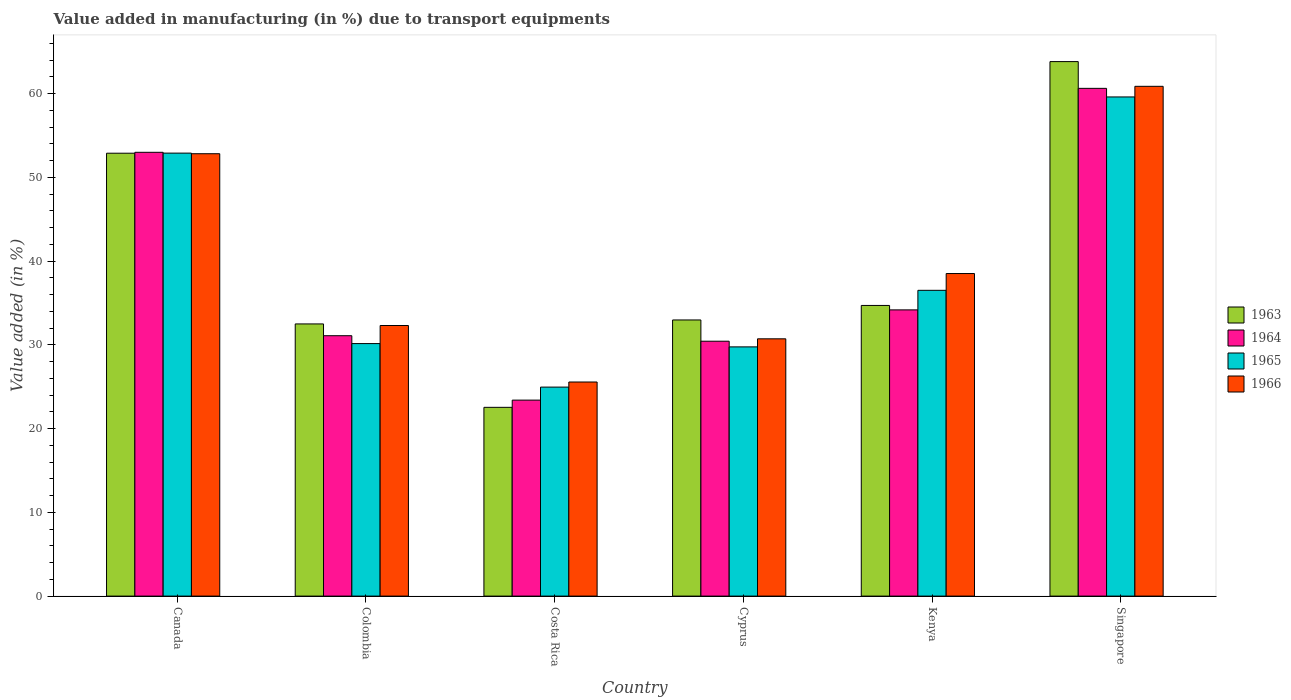How many groups of bars are there?
Offer a terse response. 6. Are the number of bars per tick equal to the number of legend labels?
Keep it short and to the point. Yes. How many bars are there on the 4th tick from the left?
Offer a terse response. 4. How many bars are there on the 1st tick from the right?
Provide a short and direct response. 4. What is the label of the 5th group of bars from the left?
Ensure brevity in your answer.  Kenya. In how many cases, is the number of bars for a given country not equal to the number of legend labels?
Provide a short and direct response. 0. What is the percentage of value added in manufacturing due to transport equipments in 1966 in Kenya?
Provide a succinct answer. 38.51. Across all countries, what is the maximum percentage of value added in manufacturing due to transport equipments in 1964?
Provide a succinct answer. 60.62. Across all countries, what is the minimum percentage of value added in manufacturing due to transport equipments in 1966?
Give a very brief answer. 25.56. In which country was the percentage of value added in manufacturing due to transport equipments in 1964 maximum?
Offer a terse response. Singapore. What is the total percentage of value added in manufacturing due to transport equipments in 1963 in the graph?
Your answer should be very brief. 239.38. What is the difference between the percentage of value added in manufacturing due to transport equipments in 1964 in Colombia and that in Singapore?
Offer a very short reply. -29.53. What is the difference between the percentage of value added in manufacturing due to transport equipments in 1965 in Costa Rica and the percentage of value added in manufacturing due to transport equipments in 1964 in Canada?
Offer a terse response. -28.03. What is the average percentage of value added in manufacturing due to transport equipments in 1966 per country?
Your response must be concise. 40.13. What is the difference between the percentage of value added in manufacturing due to transport equipments of/in 1965 and percentage of value added in manufacturing due to transport equipments of/in 1964 in Cyprus?
Provide a short and direct response. -0.68. What is the ratio of the percentage of value added in manufacturing due to transport equipments in 1966 in Canada to that in Singapore?
Provide a short and direct response. 0.87. Is the percentage of value added in manufacturing due to transport equipments in 1966 in Colombia less than that in Costa Rica?
Ensure brevity in your answer.  No. What is the difference between the highest and the second highest percentage of value added in manufacturing due to transport equipments in 1966?
Your answer should be very brief. -22.35. What is the difference between the highest and the lowest percentage of value added in manufacturing due to transport equipments in 1965?
Offer a very short reply. 34.64. In how many countries, is the percentage of value added in manufacturing due to transport equipments in 1965 greater than the average percentage of value added in manufacturing due to transport equipments in 1965 taken over all countries?
Offer a very short reply. 2. What does the 3rd bar from the left in Costa Rica represents?
Offer a very short reply. 1965. What does the 2nd bar from the right in Canada represents?
Give a very brief answer. 1965. Is it the case that in every country, the sum of the percentage of value added in manufacturing due to transport equipments in 1963 and percentage of value added in manufacturing due to transport equipments in 1964 is greater than the percentage of value added in manufacturing due to transport equipments in 1965?
Give a very brief answer. Yes. Are all the bars in the graph horizontal?
Your response must be concise. No. Are the values on the major ticks of Y-axis written in scientific E-notation?
Your answer should be very brief. No. Does the graph contain any zero values?
Ensure brevity in your answer.  No. Does the graph contain grids?
Keep it short and to the point. No. Where does the legend appear in the graph?
Provide a succinct answer. Center right. What is the title of the graph?
Offer a terse response. Value added in manufacturing (in %) due to transport equipments. Does "1968" appear as one of the legend labels in the graph?
Give a very brief answer. No. What is the label or title of the X-axis?
Keep it short and to the point. Country. What is the label or title of the Y-axis?
Provide a succinct answer. Value added (in %). What is the Value added (in %) in 1963 in Canada?
Give a very brief answer. 52.87. What is the Value added (in %) in 1964 in Canada?
Your response must be concise. 52.98. What is the Value added (in %) of 1965 in Canada?
Provide a succinct answer. 52.89. What is the Value added (in %) in 1966 in Canada?
Keep it short and to the point. 52.81. What is the Value added (in %) in 1963 in Colombia?
Make the answer very short. 32.49. What is the Value added (in %) of 1964 in Colombia?
Keep it short and to the point. 31.09. What is the Value added (in %) of 1965 in Colombia?
Make the answer very short. 30.15. What is the Value added (in %) in 1966 in Colombia?
Give a very brief answer. 32.3. What is the Value added (in %) in 1963 in Costa Rica?
Provide a short and direct response. 22.53. What is the Value added (in %) in 1964 in Costa Rica?
Your answer should be compact. 23.4. What is the Value added (in %) in 1965 in Costa Rica?
Your answer should be compact. 24.95. What is the Value added (in %) in 1966 in Costa Rica?
Your answer should be very brief. 25.56. What is the Value added (in %) of 1963 in Cyprus?
Provide a succinct answer. 32.97. What is the Value added (in %) of 1964 in Cyprus?
Your response must be concise. 30.43. What is the Value added (in %) in 1965 in Cyprus?
Your answer should be compact. 29.75. What is the Value added (in %) in 1966 in Cyprus?
Offer a very short reply. 30.72. What is the Value added (in %) of 1963 in Kenya?
Your answer should be very brief. 34.7. What is the Value added (in %) in 1964 in Kenya?
Your response must be concise. 34.17. What is the Value added (in %) of 1965 in Kenya?
Offer a terse response. 36.5. What is the Value added (in %) of 1966 in Kenya?
Offer a very short reply. 38.51. What is the Value added (in %) in 1963 in Singapore?
Offer a very short reply. 63.81. What is the Value added (in %) in 1964 in Singapore?
Offer a very short reply. 60.62. What is the Value added (in %) of 1965 in Singapore?
Offer a very short reply. 59.59. What is the Value added (in %) of 1966 in Singapore?
Provide a succinct answer. 60.86. Across all countries, what is the maximum Value added (in %) in 1963?
Provide a succinct answer. 63.81. Across all countries, what is the maximum Value added (in %) of 1964?
Keep it short and to the point. 60.62. Across all countries, what is the maximum Value added (in %) of 1965?
Your answer should be compact. 59.59. Across all countries, what is the maximum Value added (in %) in 1966?
Make the answer very short. 60.86. Across all countries, what is the minimum Value added (in %) of 1963?
Ensure brevity in your answer.  22.53. Across all countries, what is the minimum Value added (in %) in 1964?
Your response must be concise. 23.4. Across all countries, what is the minimum Value added (in %) of 1965?
Provide a succinct answer. 24.95. Across all countries, what is the minimum Value added (in %) of 1966?
Keep it short and to the point. 25.56. What is the total Value added (in %) of 1963 in the graph?
Your answer should be very brief. 239.38. What is the total Value added (in %) of 1964 in the graph?
Give a very brief answer. 232.68. What is the total Value added (in %) in 1965 in the graph?
Offer a terse response. 233.83. What is the total Value added (in %) of 1966 in the graph?
Keep it short and to the point. 240.76. What is the difference between the Value added (in %) in 1963 in Canada and that in Colombia?
Ensure brevity in your answer.  20.38. What is the difference between the Value added (in %) in 1964 in Canada and that in Colombia?
Your answer should be compact. 21.9. What is the difference between the Value added (in %) of 1965 in Canada and that in Colombia?
Your answer should be compact. 22.74. What is the difference between the Value added (in %) in 1966 in Canada and that in Colombia?
Provide a short and direct response. 20.51. What is the difference between the Value added (in %) in 1963 in Canada and that in Costa Rica?
Keep it short and to the point. 30.34. What is the difference between the Value added (in %) in 1964 in Canada and that in Costa Rica?
Offer a very short reply. 29.59. What is the difference between the Value added (in %) of 1965 in Canada and that in Costa Rica?
Your answer should be compact. 27.93. What is the difference between the Value added (in %) in 1966 in Canada and that in Costa Rica?
Ensure brevity in your answer.  27.25. What is the difference between the Value added (in %) in 1963 in Canada and that in Cyprus?
Provide a succinct answer. 19.91. What is the difference between the Value added (in %) of 1964 in Canada and that in Cyprus?
Your answer should be compact. 22.55. What is the difference between the Value added (in %) of 1965 in Canada and that in Cyprus?
Your response must be concise. 23.13. What is the difference between the Value added (in %) of 1966 in Canada and that in Cyprus?
Make the answer very short. 22.1. What is the difference between the Value added (in %) in 1963 in Canada and that in Kenya?
Offer a terse response. 18.17. What is the difference between the Value added (in %) in 1964 in Canada and that in Kenya?
Provide a short and direct response. 18.81. What is the difference between the Value added (in %) of 1965 in Canada and that in Kenya?
Offer a terse response. 16.38. What is the difference between the Value added (in %) in 1966 in Canada and that in Kenya?
Ensure brevity in your answer.  14.3. What is the difference between the Value added (in %) in 1963 in Canada and that in Singapore?
Offer a very short reply. -10.94. What is the difference between the Value added (in %) of 1964 in Canada and that in Singapore?
Ensure brevity in your answer.  -7.63. What is the difference between the Value added (in %) in 1965 in Canada and that in Singapore?
Ensure brevity in your answer.  -6.71. What is the difference between the Value added (in %) of 1966 in Canada and that in Singapore?
Provide a short and direct response. -8.05. What is the difference between the Value added (in %) in 1963 in Colombia and that in Costa Rica?
Provide a succinct answer. 9.96. What is the difference between the Value added (in %) in 1964 in Colombia and that in Costa Rica?
Your response must be concise. 7.69. What is the difference between the Value added (in %) of 1965 in Colombia and that in Costa Rica?
Offer a terse response. 5.2. What is the difference between the Value added (in %) of 1966 in Colombia and that in Costa Rica?
Provide a short and direct response. 6.74. What is the difference between the Value added (in %) in 1963 in Colombia and that in Cyprus?
Your answer should be very brief. -0.47. What is the difference between the Value added (in %) in 1964 in Colombia and that in Cyprus?
Give a very brief answer. 0.66. What is the difference between the Value added (in %) in 1965 in Colombia and that in Cyprus?
Provide a succinct answer. 0.39. What is the difference between the Value added (in %) of 1966 in Colombia and that in Cyprus?
Your answer should be very brief. 1.59. What is the difference between the Value added (in %) of 1963 in Colombia and that in Kenya?
Your answer should be compact. -2.21. What is the difference between the Value added (in %) of 1964 in Colombia and that in Kenya?
Offer a terse response. -3.08. What is the difference between the Value added (in %) of 1965 in Colombia and that in Kenya?
Your answer should be compact. -6.36. What is the difference between the Value added (in %) in 1966 in Colombia and that in Kenya?
Your answer should be very brief. -6.2. What is the difference between the Value added (in %) in 1963 in Colombia and that in Singapore?
Offer a terse response. -31.32. What is the difference between the Value added (in %) of 1964 in Colombia and that in Singapore?
Your answer should be very brief. -29.53. What is the difference between the Value added (in %) of 1965 in Colombia and that in Singapore?
Provide a short and direct response. -29.45. What is the difference between the Value added (in %) of 1966 in Colombia and that in Singapore?
Ensure brevity in your answer.  -28.56. What is the difference between the Value added (in %) in 1963 in Costa Rica and that in Cyprus?
Provide a succinct answer. -10.43. What is the difference between the Value added (in %) in 1964 in Costa Rica and that in Cyprus?
Your answer should be compact. -7.03. What is the difference between the Value added (in %) in 1965 in Costa Rica and that in Cyprus?
Your answer should be very brief. -4.8. What is the difference between the Value added (in %) in 1966 in Costa Rica and that in Cyprus?
Provide a succinct answer. -5.16. What is the difference between the Value added (in %) of 1963 in Costa Rica and that in Kenya?
Offer a terse response. -12.17. What is the difference between the Value added (in %) of 1964 in Costa Rica and that in Kenya?
Your answer should be compact. -10.77. What is the difference between the Value added (in %) of 1965 in Costa Rica and that in Kenya?
Offer a terse response. -11.55. What is the difference between the Value added (in %) of 1966 in Costa Rica and that in Kenya?
Keep it short and to the point. -12.95. What is the difference between the Value added (in %) in 1963 in Costa Rica and that in Singapore?
Offer a terse response. -41.28. What is the difference between the Value added (in %) of 1964 in Costa Rica and that in Singapore?
Provide a succinct answer. -37.22. What is the difference between the Value added (in %) in 1965 in Costa Rica and that in Singapore?
Provide a succinct answer. -34.64. What is the difference between the Value added (in %) of 1966 in Costa Rica and that in Singapore?
Your answer should be compact. -35.3. What is the difference between the Value added (in %) in 1963 in Cyprus and that in Kenya?
Keep it short and to the point. -1.73. What is the difference between the Value added (in %) in 1964 in Cyprus and that in Kenya?
Ensure brevity in your answer.  -3.74. What is the difference between the Value added (in %) in 1965 in Cyprus and that in Kenya?
Your response must be concise. -6.75. What is the difference between the Value added (in %) of 1966 in Cyprus and that in Kenya?
Your answer should be compact. -7.79. What is the difference between the Value added (in %) in 1963 in Cyprus and that in Singapore?
Ensure brevity in your answer.  -30.84. What is the difference between the Value added (in %) in 1964 in Cyprus and that in Singapore?
Provide a succinct answer. -30.19. What is the difference between the Value added (in %) of 1965 in Cyprus and that in Singapore?
Ensure brevity in your answer.  -29.84. What is the difference between the Value added (in %) in 1966 in Cyprus and that in Singapore?
Your answer should be very brief. -30.14. What is the difference between the Value added (in %) in 1963 in Kenya and that in Singapore?
Your answer should be very brief. -29.11. What is the difference between the Value added (in %) of 1964 in Kenya and that in Singapore?
Give a very brief answer. -26.45. What is the difference between the Value added (in %) of 1965 in Kenya and that in Singapore?
Provide a succinct answer. -23.09. What is the difference between the Value added (in %) in 1966 in Kenya and that in Singapore?
Provide a short and direct response. -22.35. What is the difference between the Value added (in %) of 1963 in Canada and the Value added (in %) of 1964 in Colombia?
Make the answer very short. 21.79. What is the difference between the Value added (in %) of 1963 in Canada and the Value added (in %) of 1965 in Colombia?
Provide a succinct answer. 22.73. What is the difference between the Value added (in %) in 1963 in Canada and the Value added (in %) in 1966 in Colombia?
Give a very brief answer. 20.57. What is the difference between the Value added (in %) of 1964 in Canada and the Value added (in %) of 1965 in Colombia?
Make the answer very short. 22.84. What is the difference between the Value added (in %) in 1964 in Canada and the Value added (in %) in 1966 in Colombia?
Make the answer very short. 20.68. What is the difference between the Value added (in %) of 1965 in Canada and the Value added (in %) of 1966 in Colombia?
Keep it short and to the point. 20.58. What is the difference between the Value added (in %) of 1963 in Canada and the Value added (in %) of 1964 in Costa Rica?
Make the answer very short. 29.48. What is the difference between the Value added (in %) of 1963 in Canada and the Value added (in %) of 1965 in Costa Rica?
Make the answer very short. 27.92. What is the difference between the Value added (in %) in 1963 in Canada and the Value added (in %) in 1966 in Costa Rica?
Keep it short and to the point. 27.31. What is the difference between the Value added (in %) in 1964 in Canada and the Value added (in %) in 1965 in Costa Rica?
Offer a very short reply. 28.03. What is the difference between the Value added (in %) of 1964 in Canada and the Value added (in %) of 1966 in Costa Rica?
Provide a succinct answer. 27.42. What is the difference between the Value added (in %) of 1965 in Canada and the Value added (in %) of 1966 in Costa Rica?
Make the answer very short. 27.33. What is the difference between the Value added (in %) of 1963 in Canada and the Value added (in %) of 1964 in Cyprus?
Your answer should be compact. 22.44. What is the difference between the Value added (in %) of 1963 in Canada and the Value added (in %) of 1965 in Cyprus?
Your response must be concise. 23.12. What is the difference between the Value added (in %) in 1963 in Canada and the Value added (in %) in 1966 in Cyprus?
Provide a short and direct response. 22.16. What is the difference between the Value added (in %) in 1964 in Canada and the Value added (in %) in 1965 in Cyprus?
Your response must be concise. 23.23. What is the difference between the Value added (in %) in 1964 in Canada and the Value added (in %) in 1966 in Cyprus?
Make the answer very short. 22.27. What is the difference between the Value added (in %) in 1965 in Canada and the Value added (in %) in 1966 in Cyprus?
Your answer should be compact. 22.17. What is the difference between the Value added (in %) of 1963 in Canada and the Value added (in %) of 1964 in Kenya?
Give a very brief answer. 18.7. What is the difference between the Value added (in %) in 1963 in Canada and the Value added (in %) in 1965 in Kenya?
Give a very brief answer. 16.37. What is the difference between the Value added (in %) in 1963 in Canada and the Value added (in %) in 1966 in Kenya?
Your response must be concise. 14.37. What is the difference between the Value added (in %) of 1964 in Canada and the Value added (in %) of 1965 in Kenya?
Give a very brief answer. 16.48. What is the difference between the Value added (in %) of 1964 in Canada and the Value added (in %) of 1966 in Kenya?
Keep it short and to the point. 14.47. What is the difference between the Value added (in %) in 1965 in Canada and the Value added (in %) in 1966 in Kenya?
Make the answer very short. 14.38. What is the difference between the Value added (in %) of 1963 in Canada and the Value added (in %) of 1964 in Singapore?
Give a very brief answer. -7.74. What is the difference between the Value added (in %) in 1963 in Canada and the Value added (in %) in 1965 in Singapore?
Your response must be concise. -6.72. What is the difference between the Value added (in %) of 1963 in Canada and the Value added (in %) of 1966 in Singapore?
Make the answer very short. -7.99. What is the difference between the Value added (in %) in 1964 in Canada and the Value added (in %) in 1965 in Singapore?
Ensure brevity in your answer.  -6.61. What is the difference between the Value added (in %) in 1964 in Canada and the Value added (in %) in 1966 in Singapore?
Provide a short and direct response. -7.88. What is the difference between the Value added (in %) of 1965 in Canada and the Value added (in %) of 1966 in Singapore?
Ensure brevity in your answer.  -7.97. What is the difference between the Value added (in %) in 1963 in Colombia and the Value added (in %) in 1964 in Costa Rica?
Provide a succinct answer. 9.1. What is the difference between the Value added (in %) in 1963 in Colombia and the Value added (in %) in 1965 in Costa Rica?
Provide a short and direct response. 7.54. What is the difference between the Value added (in %) in 1963 in Colombia and the Value added (in %) in 1966 in Costa Rica?
Make the answer very short. 6.93. What is the difference between the Value added (in %) of 1964 in Colombia and the Value added (in %) of 1965 in Costa Rica?
Your answer should be compact. 6.14. What is the difference between the Value added (in %) in 1964 in Colombia and the Value added (in %) in 1966 in Costa Rica?
Give a very brief answer. 5.53. What is the difference between the Value added (in %) of 1965 in Colombia and the Value added (in %) of 1966 in Costa Rica?
Give a very brief answer. 4.59. What is the difference between the Value added (in %) in 1963 in Colombia and the Value added (in %) in 1964 in Cyprus?
Provide a short and direct response. 2.06. What is the difference between the Value added (in %) in 1963 in Colombia and the Value added (in %) in 1965 in Cyprus?
Your response must be concise. 2.74. What is the difference between the Value added (in %) in 1963 in Colombia and the Value added (in %) in 1966 in Cyprus?
Your response must be concise. 1.78. What is the difference between the Value added (in %) of 1964 in Colombia and the Value added (in %) of 1965 in Cyprus?
Provide a succinct answer. 1.33. What is the difference between the Value added (in %) in 1964 in Colombia and the Value added (in %) in 1966 in Cyprus?
Give a very brief answer. 0.37. What is the difference between the Value added (in %) in 1965 in Colombia and the Value added (in %) in 1966 in Cyprus?
Provide a short and direct response. -0.57. What is the difference between the Value added (in %) of 1963 in Colombia and the Value added (in %) of 1964 in Kenya?
Your response must be concise. -1.68. What is the difference between the Value added (in %) of 1963 in Colombia and the Value added (in %) of 1965 in Kenya?
Make the answer very short. -4.01. What is the difference between the Value added (in %) in 1963 in Colombia and the Value added (in %) in 1966 in Kenya?
Provide a succinct answer. -6.01. What is the difference between the Value added (in %) of 1964 in Colombia and the Value added (in %) of 1965 in Kenya?
Your answer should be compact. -5.42. What is the difference between the Value added (in %) in 1964 in Colombia and the Value added (in %) in 1966 in Kenya?
Your answer should be compact. -7.42. What is the difference between the Value added (in %) of 1965 in Colombia and the Value added (in %) of 1966 in Kenya?
Make the answer very short. -8.36. What is the difference between the Value added (in %) of 1963 in Colombia and the Value added (in %) of 1964 in Singapore?
Your answer should be compact. -28.12. What is the difference between the Value added (in %) in 1963 in Colombia and the Value added (in %) in 1965 in Singapore?
Ensure brevity in your answer.  -27.1. What is the difference between the Value added (in %) of 1963 in Colombia and the Value added (in %) of 1966 in Singapore?
Offer a terse response. -28.37. What is the difference between the Value added (in %) in 1964 in Colombia and the Value added (in %) in 1965 in Singapore?
Give a very brief answer. -28.51. What is the difference between the Value added (in %) in 1964 in Colombia and the Value added (in %) in 1966 in Singapore?
Keep it short and to the point. -29.77. What is the difference between the Value added (in %) of 1965 in Colombia and the Value added (in %) of 1966 in Singapore?
Give a very brief answer. -30.71. What is the difference between the Value added (in %) of 1963 in Costa Rica and the Value added (in %) of 1964 in Cyprus?
Keep it short and to the point. -7.9. What is the difference between the Value added (in %) in 1963 in Costa Rica and the Value added (in %) in 1965 in Cyprus?
Keep it short and to the point. -7.22. What is the difference between the Value added (in %) of 1963 in Costa Rica and the Value added (in %) of 1966 in Cyprus?
Offer a very short reply. -8.18. What is the difference between the Value added (in %) in 1964 in Costa Rica and the Value added (in %) in 1965 in Cyprus?
Your answer should be very brief. -6.36. What is the difference between the Value added (in %) of 1964 in Costa Rica and the Value added (in %) of 1966 in Cyprus?
Keep it short and to the point. -7.32. What is the difference between the Value added (in %) of 1965 in Costa Rica and the Value added (in %) of 1966 in Cyprus?
Your response must be concise. -5.77. What is the difference between the Value added (in %) in 1963 in Costa Rica and the Value added (in %) in 1964 in Kenya?
Offer a terse response. -11.64. What is the difference between the Value added (in %) in 1963 in Costa Rica and the Value added (in %) in 1965 in Kenya?
Your answer should be very brief. -13.97. What is the difference between the Value added (in %) in 1963 in Costa Rica and the Value added (in %) in 1966 in Kenya?
Offer a terse response. -15.97. What is the difference between the Value added (in %) of 1964 in Costa Rica and the Value added (in %) of 1965 in Kenya?
Offer a very short reply. -13.11. What is the difference between the Value added (in %) of 1964 in Costa Rica and the Value added (in %) of 1966 in Kenya?
Offer a terse response. -15.11. What is the difference between the Value added (in %) in 1965 in Costa Rica and the Value added (in %) in 1966 in Kenya?
Your response must be concise. -13.56. What is the difference between the Value added (in %) in 1963 in Costa Rica and the Value added (in %) in 1964 in Singapore?
Provide a succinct answer. -38.08. What is the difference between the Value added (in %) of 1963 in Costa Rica and the Value added (in %) of 1965 in Singapore?
Offer a terse response. -37.06. What is the difference between the Value added (in %) in 1963 in Costa Rica and the Value added (in %) in 1966 in Singapore?
Give a very brief answer. -38.33. What is the difference between the Value added (in %) in 1964 in Costa Rica and the Value added (in %) in 1965 in Singapore?
Keep it short and to the point. -36.19. What is the difference between the Value added (in %) of 1964 in Costa Rica and the Value added (in %) of 1966 in Singapore?
Your answer should be very brief. -37.46. What is the difference between the Value added (in %) in 1965 in Costa Rica and the Value added (in %) in 1966 in Singapore?
Keep it short and to the point. -35.91. What is the difference between the Value added (in %) in 1963 in Cyprus and the Value added (in %) in 1964 in Kenya?
Your answer should be compact. -1.2. What is the difference between the Value added (in %) in 1963 in Cyprus and the Value added (in %) in 1965 in Kenya?
Make the answer very short. -3.54. What is the difference between the Value added (in %) in 1963 in Cyprus and the Value added (in %) in 1966 in Kenya?
Make the answer very short. -5.54. What is the difference between the Value added (in %) in 1964 in Cyprus and the Value added (in %) in 1965 in Kenya?
Make the answer very short. -6.07. What is the difference between the Value added (in %) of 1964 in Cyprus and the Value added (in %) of 1966 in Kenya?
Your response must be concise. -8.08. What is the difference between the Value added (in %) in 1965 in Cyprus and the Value added (in %) in 1966 in Kenya?
Your response must be concise. -8.75. What is the difference between the Value added (in %) of 1963 in Cyprus and the Value added (in %) of 1964 in Singapore?
Your answer should be very brief. -27.65. What is the difference between the Value added (in %) of 1963 in Cyprus and the Value added (in %) of 1965 in Singapore?
Keep it short and to the point. -26.62. What is the difference between the Value added (in %) in 1963 in Cyprus and the Value added (in %) in 1966 in Singapore?
Keep it short and to the point. -27.89. What is the difference between the Value added (in %) in 1964 in Cyprus and the Value added (in %) in 1965 in Singapore?
Offer a terse response. -29.16. What is the difference between the Value added (in %) of 1964 in Cyprus and the Value added (in %) of 1966 in Singapore?
Keep it short and to the point. -30.43. What is the difference between the Value added (in %) of 1965 in Cyprus and the Value added (in %) of 1966 in Singapore?
Your answer should be very brief. -31.11. What is the difference between the Value added (in %) of 1963 in Kenya and the Value added (in %) of 1964 in Singapore?
Provide a short and direct response. -25.92. What is the difference between the Value added (in %) in 1963 in Kenya and the Value added (in %) in 1965 in Singapore?
Give a very brief answer. -24.89. What is the difference between the Value added (in %) of 1963 in Kenya and the Value added (in %) of 1966 in Singapore?
Make the answer very short. -26.16. What is the difference between the Value added (in %) in 1964 in Kenya and the Value added (in %) in 1965 in Singapore?
Ensure brevity in your answer.  -25.42. What is the difference between the Value added (in %) of 1964 in Kenya and the Value added (in %) of 1966 in Singapore?
Your answer should be compact. -26.69. What is the difference between the Value added (in %) in 1965 in Kenya and the Value added (in %) in 1966 in Singapore?
Keep it short and to the point. -24.36. What is the average Value added (in %) in 1963 per country?
Provide a succinct answer. 39.9. What is the average Value added (in %) in 1964 per country?
Offer a very short reply. 38.78. What is the average Value added (in %) in 1965 per country?
Give a very brief answer. 38.97. What is the average Value added (in %) in 1966 per country?
Offer a terse response. 40.13. What is the difference between the Value added (in %) of 1963 and Value added (in %) of 1964 in Canada?
Provide a succinct answer. -0.11. What is the difference between the Value added (in %) of 1963 and Value added (in %) of 1965 in Canada?
Provide a short and direct response. -0.01. What is the difference between the Value added (in %) of 1963 and Value added (in %) of 1966 in Canada?
Give a very brief answer. 0.06. What is the difference between the Value added (in %) of 1964 and Value added (in %) of 1965 in Canada?
Keep it short and to the point. 0.1. What is the difference between the Value added (in %) in 1964 and Value added (in %) in 1966 in Canada?
Your answer should be very brief. 0.17. What is the difference between the Value added (in %) of 1965 and Value added (in %) of 1966 in Canada?
Offer a very short reply. 0.07. What is the difference between the Value added (in %) of 1963 and Value added (in %) of 1964 in Colombia?
Your response must be concise. 1.41. What is the difference between the Value added (in %) in 1963 and Value added (in %) in 1965 in Colombia?
Give a very brief answer. 2.35. What is the difference between the Value added (in %) in 1963 and Value added (in %) in 1966 in Colombia?
Offer a terse response. 0.19. What is the difference between the Value added (in %) of 1964 and Value added (in %) of 1965 in Colombia?
Provide a short and direct response. 0.94. What is the difference between the Value added (in %) of 1964 and Value added (in %) of 1966 in Colombia?
Your answer should be compact. -1.22. What is the difference between the Value added (in %) in 1965 and Value added (in %) in 1966 in Colombia?
Provide a succinct answer. -2.16. What is the difference between the Value added (in %) of 1963 and Value added (in %) of 1964 in Costa Rica?
Your response must be concise. -0.86. What is the difference between the Value added (in %) of 1963 and Value added (in %) of 1965 in Costa Rica?
Keep it short and to the point. -2.42. What is the difference between the Value added (in %) of 1963 and Value added (in %) of 1966 in Costa Rica?
Give a very brief answer. -3.03. What is the difference between the Value added (in %) in 1964 and Value added (in %) in 1965 in Costa Rica?
Keep it short and to the point. -1.55. What is the difference between the Value added (in %) in 1964 and Value added (in %) in 1966 in Costa Rica?
Offer a very short reply. -2.16. What is the difference between the Value added (in %) of 1965 and Value added (in %) of 1966 in Costa Rica?
Keep it short and to the point. -0.61. What is the difference between the Value added (in %) of 1963 and Value added (in %) of 1964 in Cyprus?
Provide a succinct answer. 2.54. What is the difference between the Value added (in %) in 1963 and Value added (in %) in 1965 in Cyprus?
Your response must be concise. 3.21. What is the difference between the Value added (in %) in 1963 and Value added (in %) in 1966 in Cyprus?
Provide a short and direct response. 2.25. What is the difference between the Value added (in %) of 1964 and Value added (in %) of 1965 in Cyprus?
Offer a terse response. 0.68. What is the difference between the Value added (in %) of 1964 and Value added (in %) of 1966 in Cyprus?
Provide a short and direct response. -0.29. What is the difference between the Value added (in %) of 1965 and Value added (in %) of 1966 in Cyprus?
Your response must be concise. -0.96. What is the difference between the Value added (in %) of 1963 and Value added (in %) of 1964 in Kenya?
Your answer should be very brief. 0.53. What is the difference between the Value added (in %) in 1963 and Value added (in %) in 1965 in Kenya?
Offer a very short reply. -1.8. What is the difference between the Value added (in %) of 1963 and Value added (in %) of 1966 in Kenya?
Your answer should be compact. -3.81. What is the difference between the Value added (in %) in 1964 and Value added (in %) in 1965 in Kenya?
Your answer should be very brief. -2.33. What is the difference between the Value added (in %) in 1964 and Value added (in %) in 1966 in Kenya?
Provide a short and direct response. -4.34. What is the difference between the Value added (in %) of 1965 and Value added (in %) of 1966 in Kenya?
Keep it short and to the point. -2. What is the difference between the Value added (in %) of 1963 and Value added (in %) of 1964 in Singapore?
Your response must be concise. 3.19. What is the difference between the Value added (in %) in 1963 and Value added (in %) in 1965 in Singapore?
Offer a terse response. 4.22. What is the difference between the Value added (in %) in 1963 and Value added (in %) in 1966 in Singapore?
Offer a terse response. 2.95. What is the difference between the Value added (in %) of 1964 and Value added (in %) of 1965 in Singapore?
Your answer should be compact. 1.03. What is the difference between the Value added (in %) in 1964 and Value added (in %) in 1966 in Singapore?
Your response must be concise. -0.24. What is the difference between the Value added (in %) of 1965 and Value added (in %) of 1966 in Singapore?
Make the answer very short. -1.27. What is the ratio of the Value added (in %) of 1963 in Canada to that in Colombia?
Give a very brief answer. 1.63. What is the ratio of the Value added (in %) of 1964 in Canada to that in Colombia?
Your answer should be very brief. 1.7. What is the ratio of the Value added (in %) of 1965 in Canada to that in Colombia?
Give a very brief answer. 1.75. What is the ratio of the Value added (in %) in 1966 in Canada to that in Colombia?
Ensure brevity in your answer.  1.63. What is the ratio of the Value added (in %) in 1963 in Canada to that in Costa Rica?
Provide a short and direct response. 2.35. What is the ratio of the Value added (in %) of 1964 in Canada to that in Costa Rica?
Keep it short and to the point. 2.26. What is the ratio of the Value added (in %) in 1965 in Canada to that in Costa Rica?
Provide a succinct answer. 2.12. What is the ratio of the Value added (in %) of 1966 in Canada to that in Costa Rica?
Offer a very short reply. 2.07. What is the ratio of the Value added (in %) of 1963 in Canada to that in Cyprus?
Ensure brevity in your answer.  1.6. What is the ratio of the Value added (in %) in 1964 in Canada to that in Cyprus?
Offer a terse response. 1.74. What is the ratio of the Value added (in %) in 1965 in Canada to that in Cyprus?
Ensure brevity in your answer.  1.78. What is the ratio of the Value added (in %) of 1966 in Canada to that in Cyprus?
Make the answer very short. 1.72. What is the ratio of the Value added (in %) of 1963 in Canada to that in Kenya?
Provide a succinct answer. 1.52. What is the ratio of the Value added (in %) in 1964 in Canada to that in Kenya?
Keep it short and to the point. 1.55. What is the ratio of the Value added (in %) in 1965 in Canada to that in Kenya?
Your response must be concise. 1.45. What is the ratio of the Value added (in %) in 1966 in Canada to that in Kenya?
Make the answer very short. 1.37. What is the ratio of the Value added (in %) in 1963 in Canada to that in Singapore?
Your response must be concise. 0.83. What is the ratio of the Value added (in %) of 1964 in Canada to that in Singapore?
Keep it short and to the point. 0.87. What is the ratio of the Value added (in %) in 1965 in Canada to that in Singapore?
Your response must be concise. 0.89. What is the ratio of the Value added (in %) of 1966 in Canada to that in Singapore?
Your answer should be compact. 0.87. What is the ratio of the Value added (in %) of 1963 in Colombia to that in Costa Rica?
Offer a terse response. 1.44. What is the ratio of the Value added (in %) in 1964 in Colombia to that in Costa Rica?
Provide a short and direct response. 1.33. What is the ratio of the Value added (in %) of 1965 in Colombia to that in Costa Rica?
Ensure brevity in your answer.  1.21. What is the ratio of the Value added (in %) in 1966 in Colombia to that in Costa Rica?
Your response must be concise. 1.26. What is the ratio of the Value added (in %) of 1963 in Colombia to that in Cyprus?
Offer a terse response. 0.99. What is the ratio of the Value added (in %) of 1964 in Colombia to that in Cyprus?
Your answer should be compact. 1.02. What is the ratio of the Value added (in %) in 1965 in Colombia to that in Cyprus?
Provide a succinct answer. 1.01. What is the ratio of the Value added (in %) in 1966 in Colombia to that in Cyprus?
Make the answer very short. 1.05. What is the ratio of the Value added (in %) in 1963 in Colombia to that in Kenya?
Give a very brief answer. 0.94. What is the ratio of the Value added (in %) of 1964 in Colombia to that in Kenya?
Give a very brief answer. 0.91. What is the ratio of the Value added (in %) of 1965 in Colombia to that in Kenya?
Offer a very short reply. 0.83. What is the ratio of the Value added (in %) of 1966 in Colombia to that in Kenya?
Keep it short and to the point. 0.84. What is the ratio of the Value added (in %) of 1963 in Colombia to that in Singapore?
Your response must be concise. 0.51. What is the ratio of the Value added (in %) of 1964 in Colombia to that in Singapore?
Keep it short and to the point. 0.51. What is the ratio of the Value added (in %) in 1965 in Colombia to that in Singapore?
Your answer should be compact. 0.51. What is the ratio of the Value added (in %) of 1966 in Colombia to that in Singapore?
Offer a terse response. 0.53. What is the ratio of the Value added (in %) of 1963 in Costa Rica to that in Cyprus?
Offer a very short reply. 0.68. What is the ratio of the Value added (in %) of 1964 in Costa Rica to that in Cyprus?
Give a very brief answer. 0.77. What is the ratio of the Value added (in %) of 1965 in Costa Rica to that in Cyprus?
Your answer should be very brief. 0.84. What is the ratio of the Value added (in %) of 1966 in Costa Rica to that in Cyprus?
Offer a terse response. 0.83. What is the ratio of the Value added (in %) of 1963 in Costa Rica to that in Kenya?
Your answer should be very brief. 0.65. What is the ratio of the Value added (in %) in 1964 in Costa Rica to that in Kenya?
Ensure brevity in your answer.  0.68. What is the ratio of the Value added (in %) of 1965 in Costa Rica to that in Kenya?
Your answer should be compact. 0.68. What is the ratio of the Value added (in %) of 1966 in Costa Rica to that in Kenya?
Keep it short and to the point. 0.66. What is the ratio of the Value added (in %) in 1963 in Costa Rica to that in Singapore?
Provide a short and direct response. 0.35. What is the ratio of the Value added (in %) in 1964 in Costa Rica to that in Singapore?
Provide a succinct answer. 0.39. What is the ratio of the Value added (in %) of 1965 in Costa Rica to that in Singapore?
Your response must be concise. 0.42. What is the ratio of the Value added (in %) of 1966 in Costa Rica to that in Singapore?
Your response must be concise. 0.42. What is the ratio of the Value added (in %) of 1963 in Cyprus to that in Kenya?
Offer a terse response. 0.95. What is the ratio of the Value added (in %) in 1964 in Cyprus to that in Kenya?
Keep it short and to the point. 0.89. What is the ratio of the Value added (in %) of 1965 in Cyprus to that in Kenya?
Make the answer very short. 0.82. What is the ratio of the Value added (in %) of 1966 in Cyprus to that in Kenya?
Provide a short and direct response. 0.8. What is the ratio of the Value added (in %) of 1963 in Cyprus to that in Singapore?
Provide a short and direct response. 0.52. What is the ratio of the Value added (in %) in 1964 in Cyprus to that in Singapore?
Give a very brief answer. 0.5. What is the ratio of the Value added (in %) of 1965 in Cyprus to that in Singapore?
Keep it short and to the point. 0.5. What is the ratio of the Value added (in %) of 1966 in Cyprus to that in Singapore?
Your answer should be very brief. 0.5. What is the ratio of the Value added (in %) of 1963 in Kenya to that in Singapore?
Provide a short and direct response. 0.54. What is the ratio of the Value added (in %) in 1964 in Kenya to that in Singapore?
Make the answer very short. 0.56. What is the ratio of the Value added (in %) of 1965 in Kenya to that in Singapore?
Make the answer very short. 0.61. What is the ratio of the Value added (in %) of 1966 in Kenya to that in Singapore?
Offer a very short reply. 0.63. What is the difference between the highest and the second highest Value added (in %) in 1963?
Offer a terse response. 10.94. What is the difference between the highest and the second highest Value added (in %) of 1964?
Ensure brevity in your answer.  7.63. What is the difference between the highest and the second highest Value added (in %) of 1965?
Make the answer very short. 6.71. What is the difference between the highest and the second highest Value added (in %) in 1966?
Your answer should be compact. 8.05. What is the difference between the highest and the lowest Value added (in %) of 1963?
Ensure brevity in your answer.  41.28. What is the difference between the highest and the lowest Value added (in %) in 1964?
Make the answer very short. 37.22. What is the difference between the highest and the lowest Value added (in %) in 1965?
Your answer should be very brief. 34.64. What is the difference between the highest and the lowest Value added (in %) of 1966?
Keep it short and to the point. 35.3. 